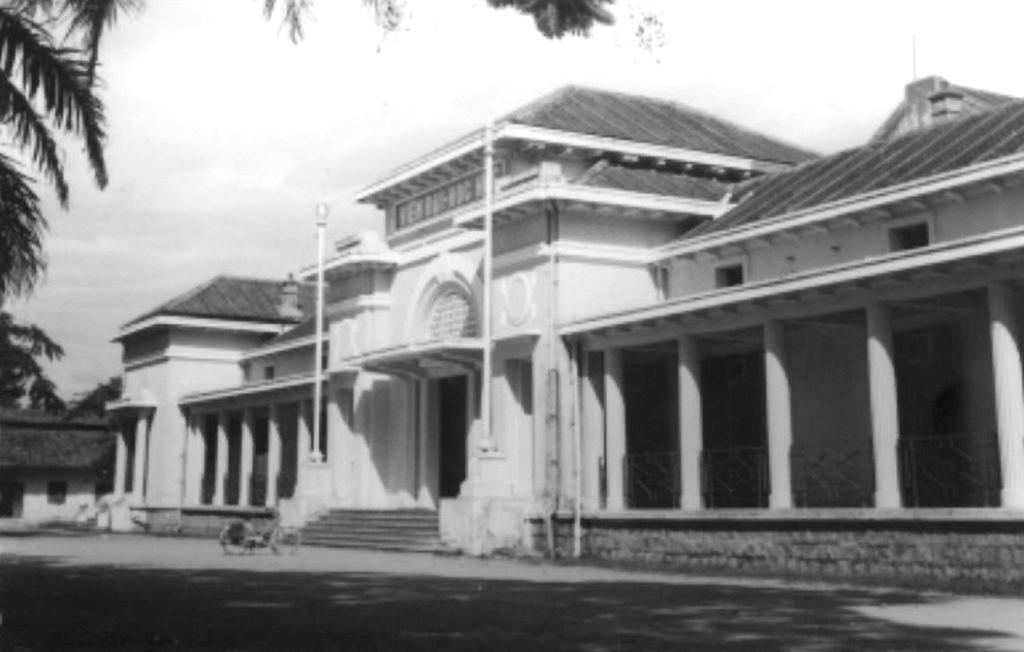What is the color scheme of the image? The image is black and white. What type of structure can be seen in the image? There is a building in the image. What architectural features are present in the image? There are pillars, stairs, and a pole in the image. What type of vegetation is visible in the image? There are trees in the image. What type of path is present in the image? There is a footpath in the image. What part of the natural environment is visible in the image? The sky is visible in the image. What type of reaction can be seen from the spy in the image? There is no spy present in the image, so no reaction can be observed. What type of jar is visible on the footpath in the image? There is no jar present on the footpath in the image. 